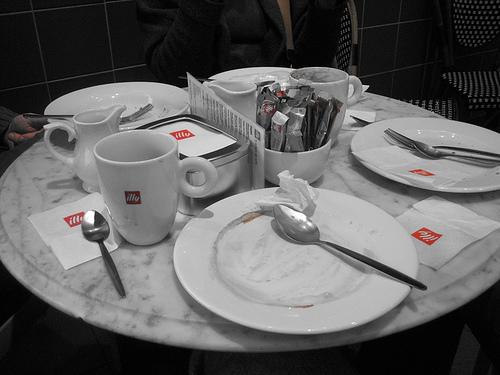How many place settings are visible?
Short answer required. 4. Does the coffee mug have a logo on it?
Answer briefly. Yes. Is anyone seated at this table?
Give a very brief answer. No. 